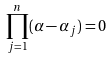Convert formula to latex. <formula><loc_0><loc_0><loc_500><loc_500>\prod _ { j = 1 } ^ { n } ( \alpha - \alpha _ { j } ) = 0 \,</formula> 